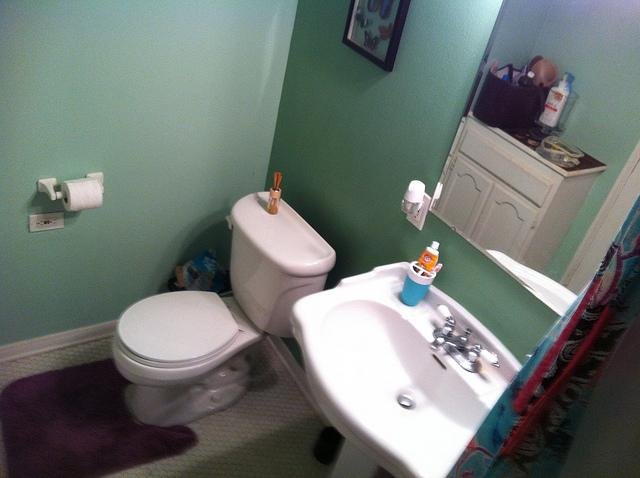What is likely in the large bottle in the reflection?

Choices:
A) conditioner
B) sunscreen
C) shampoo
D) lotion lotion 